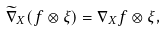<formula> <loc_0><loc_0><loc_500><loc_500>\widetilde { \nabla } _ { X } ( f \otimes \xi ) = \nabla _ { X } f \otimes \xi ,</formula> 